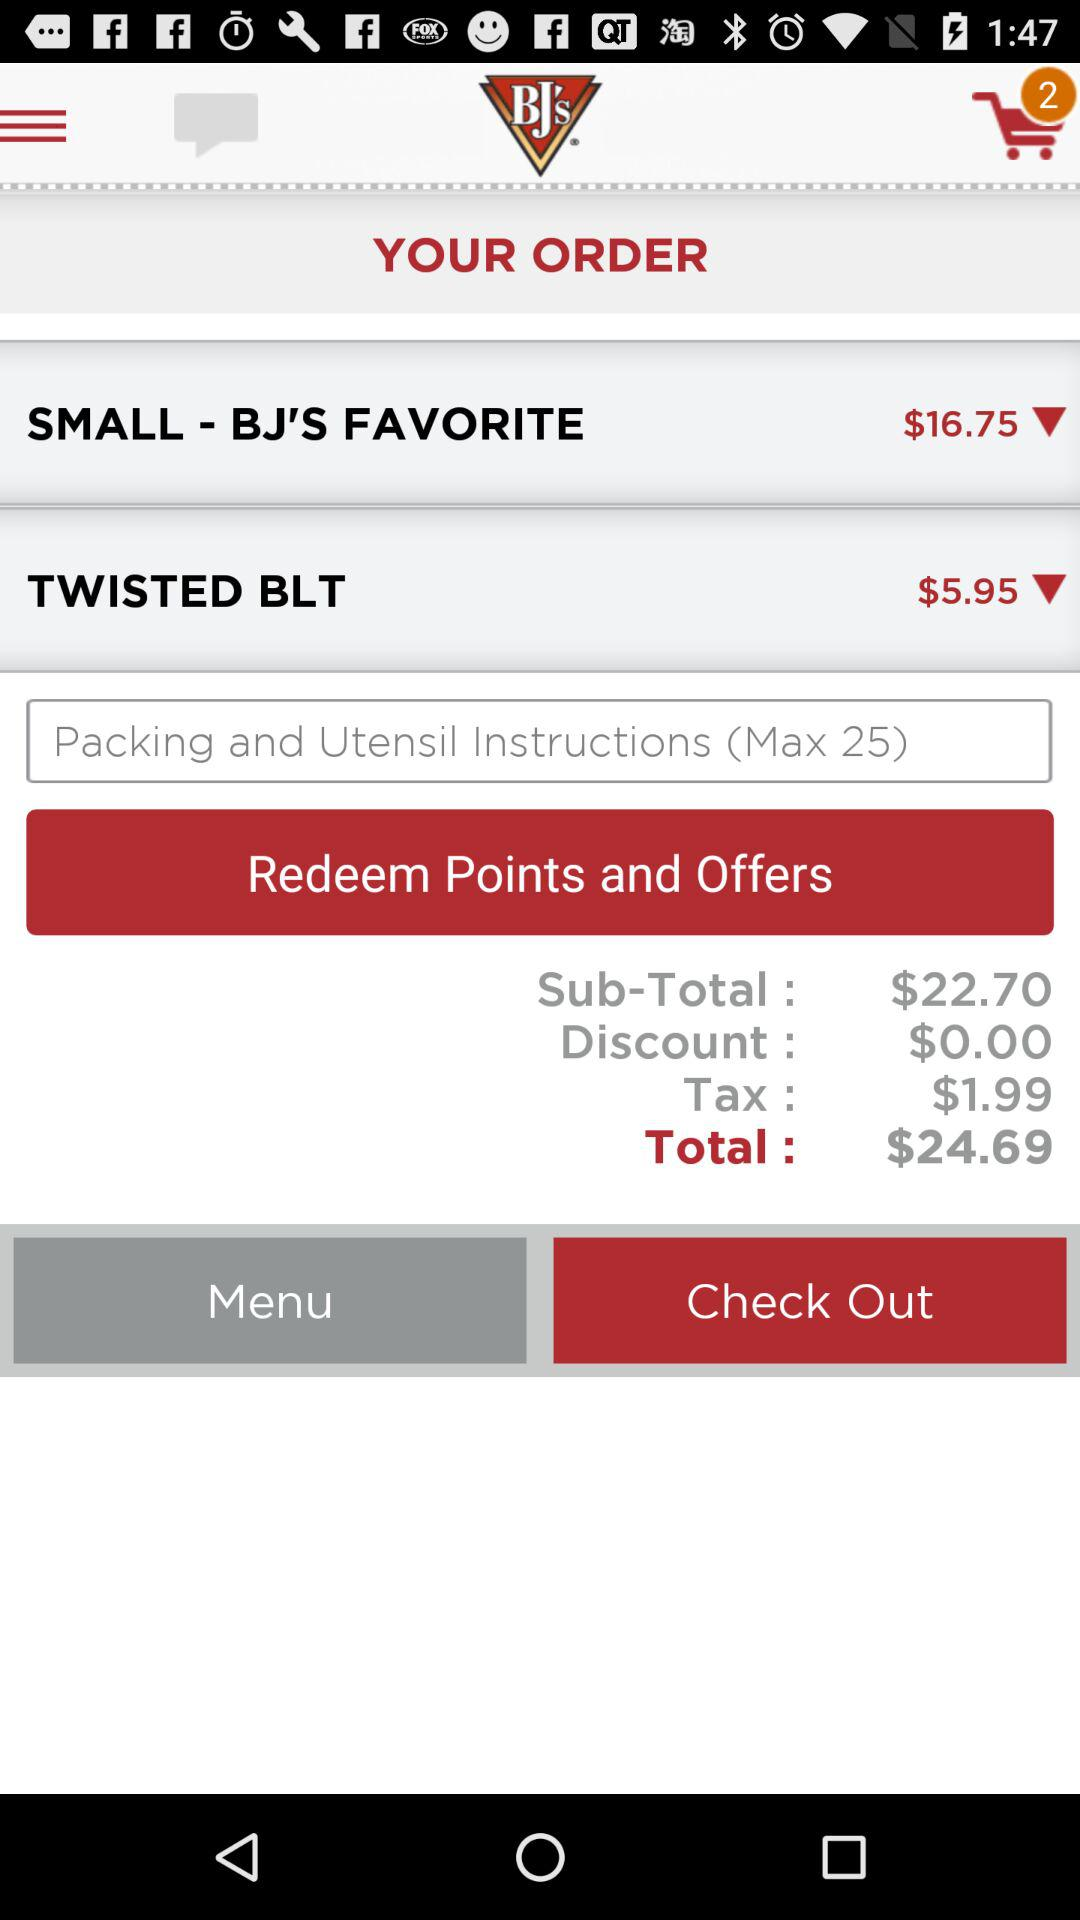Which are the different orders? The different orders are "SMALL - BJ'S FAVORITE" and "TWISTED BLT". 